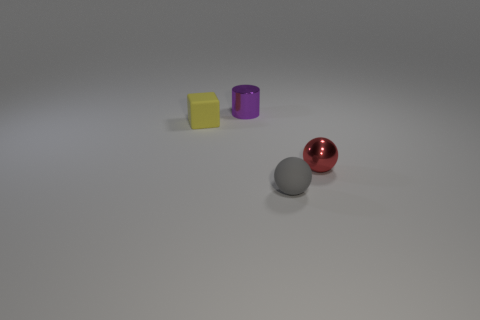Is the number of small yellow blocks greater than the number of purple blocks?
Offer a very short reply. Yes. What material is the cube?
Your answer should be compact. Rubber. Are there any small things that are behind the metal thing that is in front of the small matte block?
Your response must be concise. Yes. Is the color of the small rubber block the same as the small metallic cylinder?
Ensure brevity in your answer.  No. How many other objects are there of the same shape as the tiny purple thing?
Keep it short and to the point. 0. Are there more tiny metal objects right of the small yellow matte thing than rubber cubes that are behind the small gray matte ball?
Offer a very short reply. Yes. There is a metal object that is behind the yellow matte object; is it the same size as the sphere to the right of the gray matte ball?
Keep it short and to the point. Yes. The purple metallic object is what shape?
Your answer should be compact. Cylinder. The tiny cylinder that is the same material as the tiny red thing is what color?
Give a very brief answer. Purple. Do the tiny red sphere and the gray ball right of the tiny purple thing have the same material?
Give a very brief answer. No. 